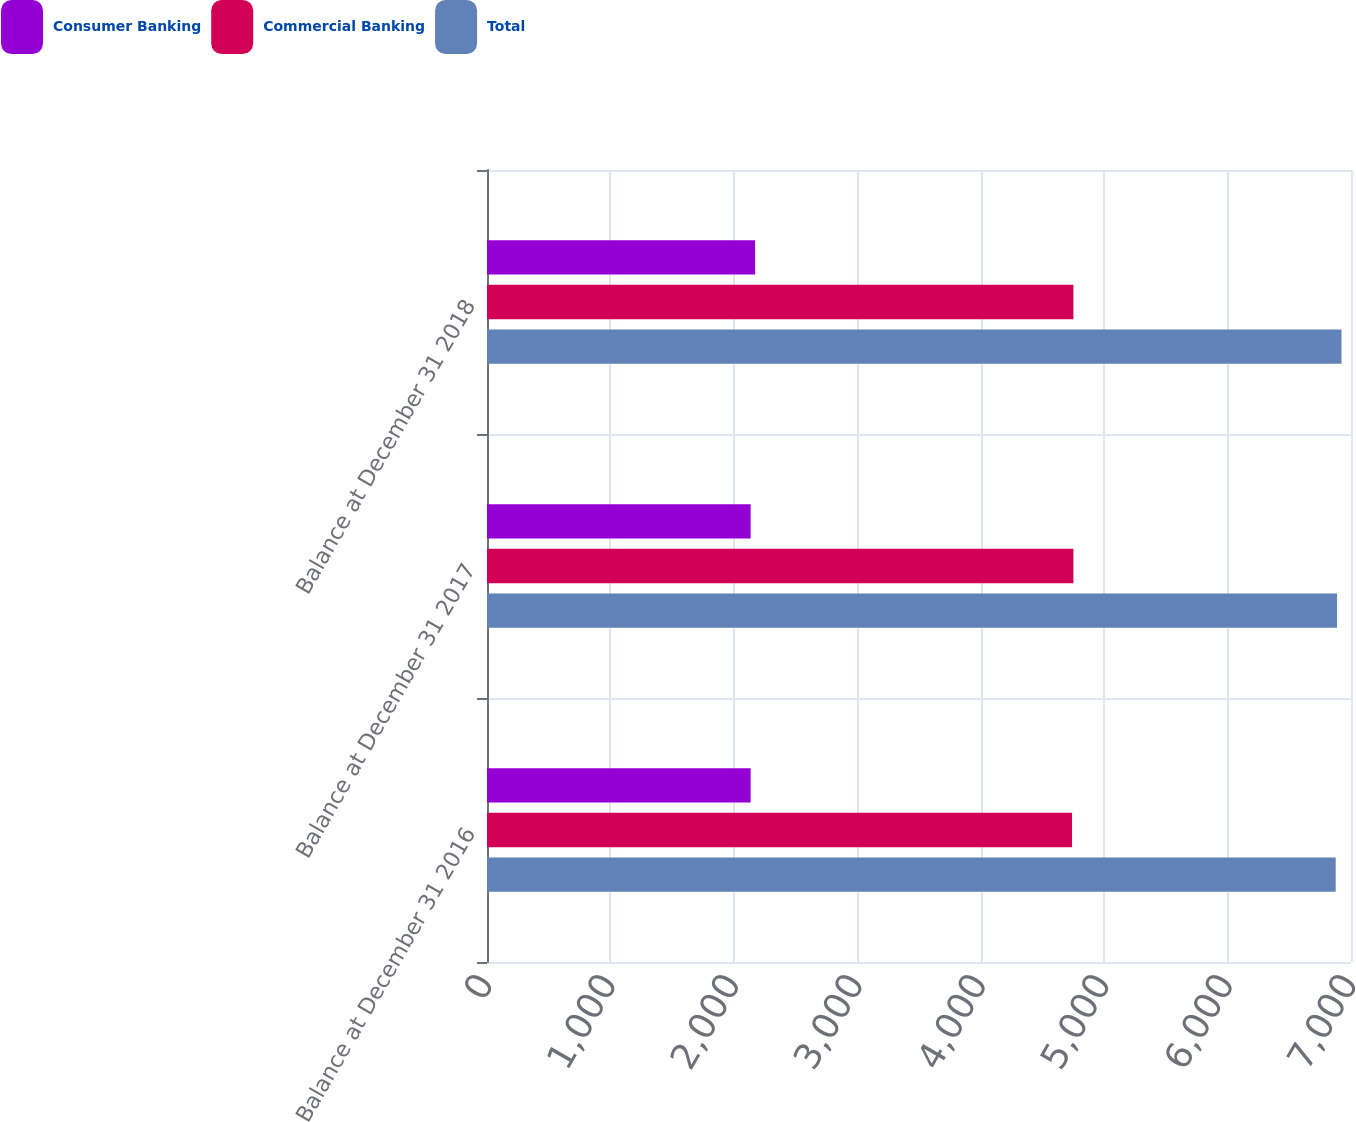<chart> <loc_0><loc_0><loc_500><loc_500><stacked_bar_chart><ecel><fcel>Balance at December 31 2016<fcel>Balance at December 31 2017<fcel>Balance at December 31 2018<nl><fcel>Consumer Banking<fcel>2136<fcel>2136<fcel>2172<nl><fcel>Commercial Banking<fcel>4740<fcel>4751<fcel>4751<nl><fcel>Total<fcel>6876<fcel>6887<fcel>6923<nl></chart> 